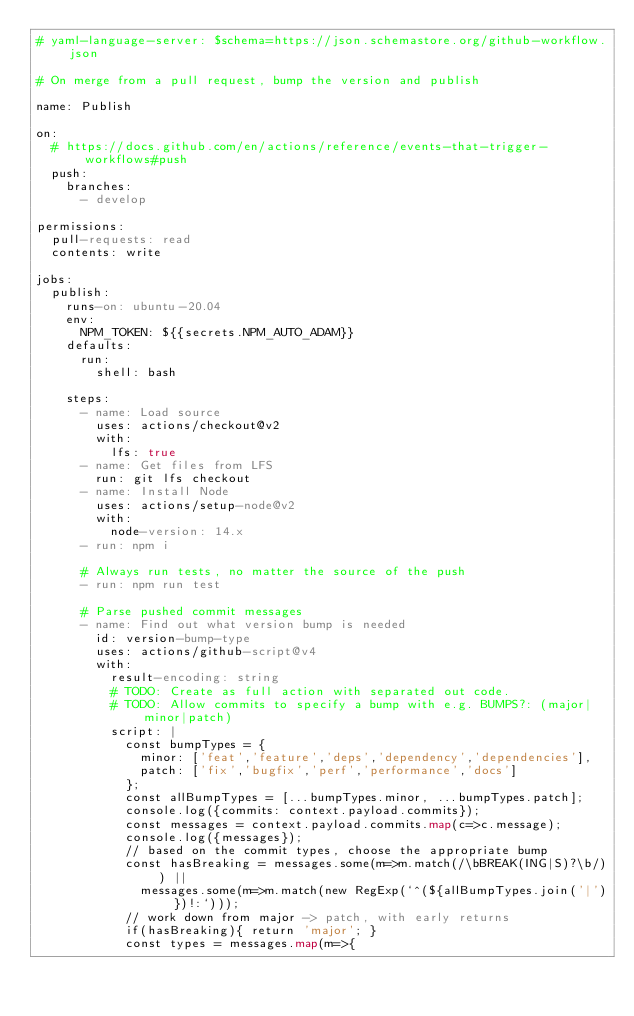Convert code to text. <code><loc_0><loc_0><loc_500><loc_500><_YAML_># yaml-language-server: $schema=https://json.schemastore.org/github-workflow.json

# On merge from a pull request, bump the version and publish

name: Publish

on:
  # https://docs.github.com/en/actions/reference/events-that-trigger-workflows#push
  push:
    branches:
      - develop

permissions:
  pull-requests: read
  contents: write

jobs:
  publish:
    runs-on: ubuntu-20.04
    env:
      NPM_TOKEN: ${{secrets.NPM_AUTO_ADAM}}
    defaults:
      run:
        shell: bash
    
    steps:
      - name: Load source
        uses: actions/checkout@v2
        with:
          lfs: true
      - name: Get files from LFS
        run: git lfs checkout
      - name: Install Node
        uses: actions/setup-node@v2
        with:
          node-version: 14.x
      - run: npm i

      # Always run tests, no matter the source of the push
      - run: npm run test

      # Parse pushed commit messages
      - name: Find out what version bump is needed
        id: version-bump-type
        uses: actions/github-script@v4
        with:
          result-encoding: string
          # TODO: Create as full action with separated out code.
          # TODO: Allow commits to specify a bump with e.g. BUMPS?: (major|minor|patch)
          script: |
            const bumpTypes = {
              minor: ['feat','feature','deps','dependency','dependencies'],
              patch: ['fix','bugfix','perf','performance','docs']
            };
            const allBumpTypes = [...bumpTypes.minor, ...bumpTypes.patch];
            console.log({commits: context.payload.commits});
            const messages = context.payload.commits.map(c=>c.message);
            console.log({messages});
            // based on the commit types, choose the appropriate bump
            const hasBreaking = messages.some(m=>m.match(/\bBREAK(ING|S)?\b/)) ||
              messages.some(m=>m.match(new RegExp(`^(${allBumpTypes.join('|')})!:`)));
            // work down from major -> patch, with early returns
            if(hasBreaking){ return 'major'; }
            const types = messages.map(m=>{</code> 